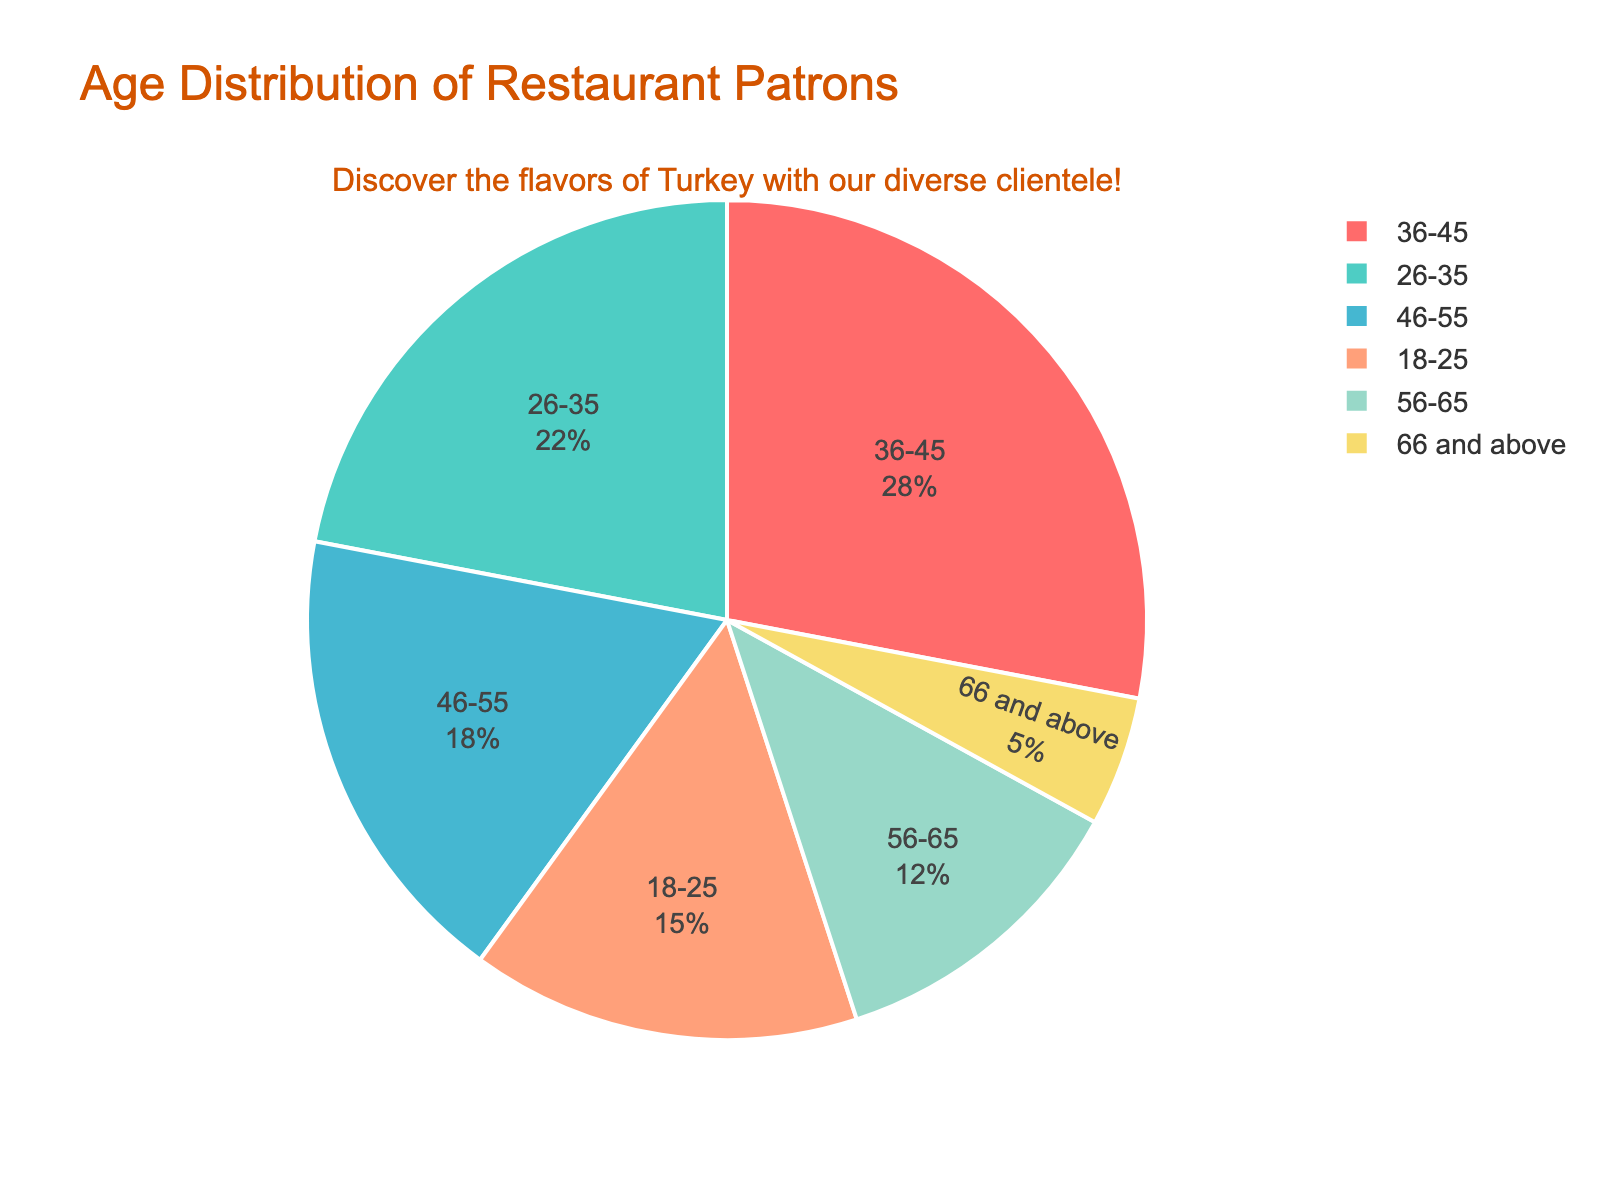What proportion of restaurant patrons are aged 26-35 and 46-55 combined? Sum the percentages of the 26-35 and 46-55 groups: 22% + 18% = 40%
Answer: 40% Which age group constitutes the smallest portion of restaurant patrons? Identify the age group with the smallest percentage from the figure. The age group 66 and above has the smallest percentage at 5%.
Answer: 66 and above How much more popular is the 36-45 age group compared to the 18-25 age group? Subtract the percentage of the 18-25 group from the 36-45 group: 28% - 15% = 13%
Answer: 13% What is the total percentage of patrons aged 45 and above? Sum the percentages of the 46-55, 56-65, and 66 and above groups: 18% + 12% + 5% = 35%
Answer: 35% Which two age groups have a combined share closest to 50%? Sum the percentages of different pairs to identify the pair close to 50%. The combined percentage of the 36-45 and 26-35 groups is 28% + 22% = 50%.
Answer: 36-45 and 26-35 Which age group has the second highest representation among the patrons? Identify the age group with the second highest percentage from the figure. The age group 26-35 has the second highest percentage after 36-45.
Answer: 26-35 Of the age groups represented, are there more patrons aged 36-55 or aged 18-35? Sum the percentages of the 36-45 and 46-55 groups: 28% + 18% = 46%, and sum the percentages of the 18-25 and 26-35 groups: 15% + 22% = 37%. 46% > 37%.
Answer: 36-55 What is the most visually prominent color on the pie chart? Identify the segment with the largest percentage and describe the color. The largest segment (36-45) is depicted in dark turquoise.
Answer: Dark turquoise 